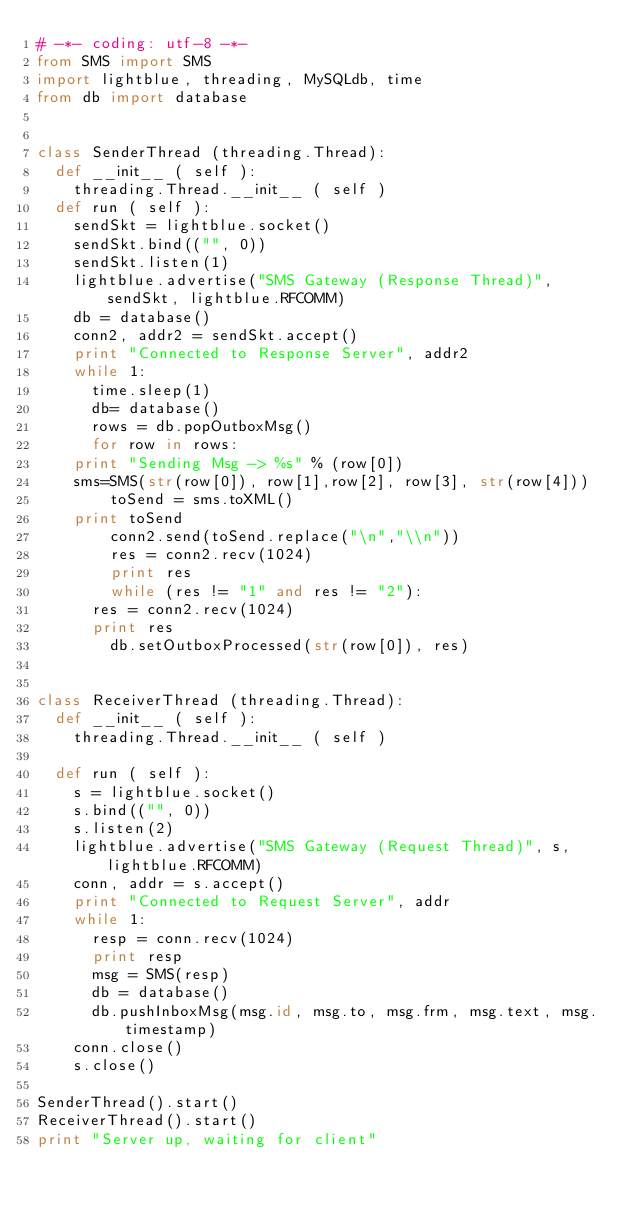<code> <loc_0><loc_0><loc_500><loc_500><_Python_># -*- coding: utf-8 -*-
from SMS import SMS
import lightblue, threading, MySQLdb, time
from db import database


class SenderThread (threading.Thread):
  def __init__ ( self ):
    threading.Thread.__init__ ( self )
  def run ( self ):
    sendSkt = lightblue.socket()
    sendSkt.bind(("", 0))  
    sendSkt.listen(1)
    lightblue.advertise("SMS Gateway (Response Thread)", sendSkt, lightblue.RFCOMM)
    db = database()
    conn2, addr2 = sendSkt.accept()
    print "Connected to Response Server", addr2
    while 1:
      time.sleep(1)
      db= database()
      rows = db.popOutboxMsg()
      for row in rows:
	print "Sending Msg -> %s" % (row[0])
	sms=SMS(str(row[0]), row[1],row[2], row[3], str(row[4]))
        toSend = sms.toXML()
	print toSend
        conn2.send(toSend.replace("\n","\\n"))
        res = conn2.recv(1024)
        print res
        while (res != "1" and res != "2"):
	  res = conn2.recv(1024)
	  print res
        db.setOutboxProcessed(str(row[0]), res) 


class ReceiverThread (threading.Thread):
  def __init__ ( self ):
    threading.Thread.__init__ ( self )
  
  def run ( self ):
    s = lightblue.socket()
    s.bind(("", 0))
    s.listen(2)
    lightblue.advertise("SMS Gateway (Request Thread)", s, lightblue.RFCOMM) 
    conn, addr = s.accept()
    print "Connected to Request Server", addr
    while 1:
      resp = conn.recv(1024)
      print resp
      msg = SMS(resp)
      db = database()
      db.pushInboxMsg(msg.id, msg.to, msg.frm, msg.text, msg.timestamp)
    conn.close()
    s.close() 
      
SenderThread().start()
ReceiverThread().start()
print "Server up, waiting for client"
</code> 